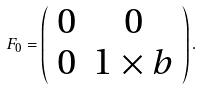<formula> <loc_0><loc_0><loc_500><loc_500>F _ { 0 } = \left ( \begin{array} { c c } 0 & { 0 } \\ { 0 } & { 1 } \times { b } \end{array} \right ) .</formula> 